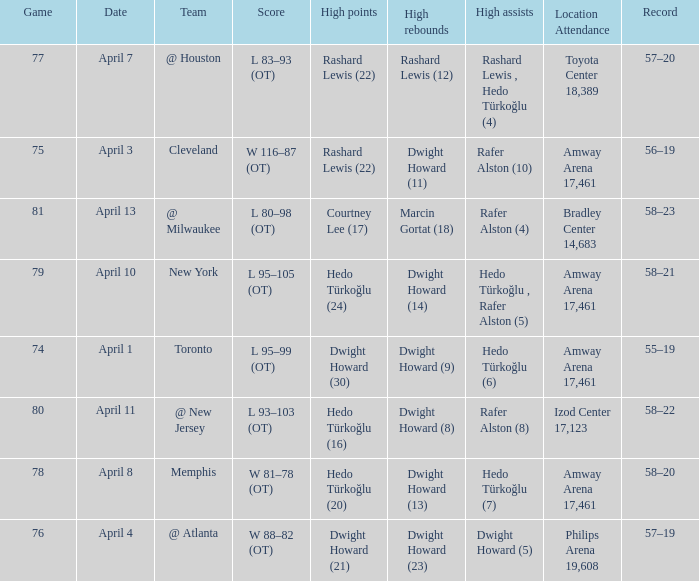What was the score in game 81? L 80–98 (OT). Write the full table. {'header': ['Game', 'Date', 'Team', 'Score', 'High points', 'High rebounds', 'High assists', 'Location Attendance', 'Record'], 'rows': [['77', 'April 7', '@ Houston', 'L 83–93 (OT)', 'Rashard Lewis (22)', 'Rashard Lewis (12)', 'Rashard Lewis , Hedo Türkoğlu (4)', 'Toyota Center 18,389', '57–20'], ['75', 'April 3', 'Cleveland', 'W 116–87 (OT)', 'Rashard Lewis (22)', 'Dwight Howard (11)', 'Rafer Alston (10)', 'Amway Arena 17,461', '56–19'], ['81', 'April 13', '@ Milwaukee', 'L 80–98 (OT)', 'Courtney Lee (17)', 'Marcin Gortat (18)', 'Rafer Alston (4)', 'Bradley Center 14,683', '58–23'], ['79', 'April 10', 'New York', 'L 95–105 (OT)', 'Hedo Türkoğlu (24)', 'Dwight Howard (14)', 'Hedo Türkoğlu , Rafer Alston (5)', 'Amway Arena 17,461', '58–21'], ['74', 'April 1', 'Toronto', 'L 95–99 (OT)', 'Dwight Howard (30)', 'Dwight Howard (9)', 'Hedo Türkoğlu (6)', 'Amway Arena 17,461', '55–19'], ['80', 'April 11', '@ New Jersey', 'L 93–103 (OT)', 'Hedo Türkoğlu (16)', 'Dwight Howard (8)', 'Rafer Alston (8)', 'Izod Center 17,123', '58–22'], ['78', 'April 8', 'Memphis', 'W 81–78 (OT)', 'Hedo Türkoğlu (20)', 'Dwight Howard (13)', 'Hedo Türkoğlu (7)', 'Amway Arena 17,461', '58–20'], ['76', 'April 4', '@ Atlanta', 'W 88–82 (OT)', 'Dwight Howard (21)', 'Dwight Howard (23)', 'Dwight Howard (5)', 'Philips Arena 19,608', '57–19']]} 